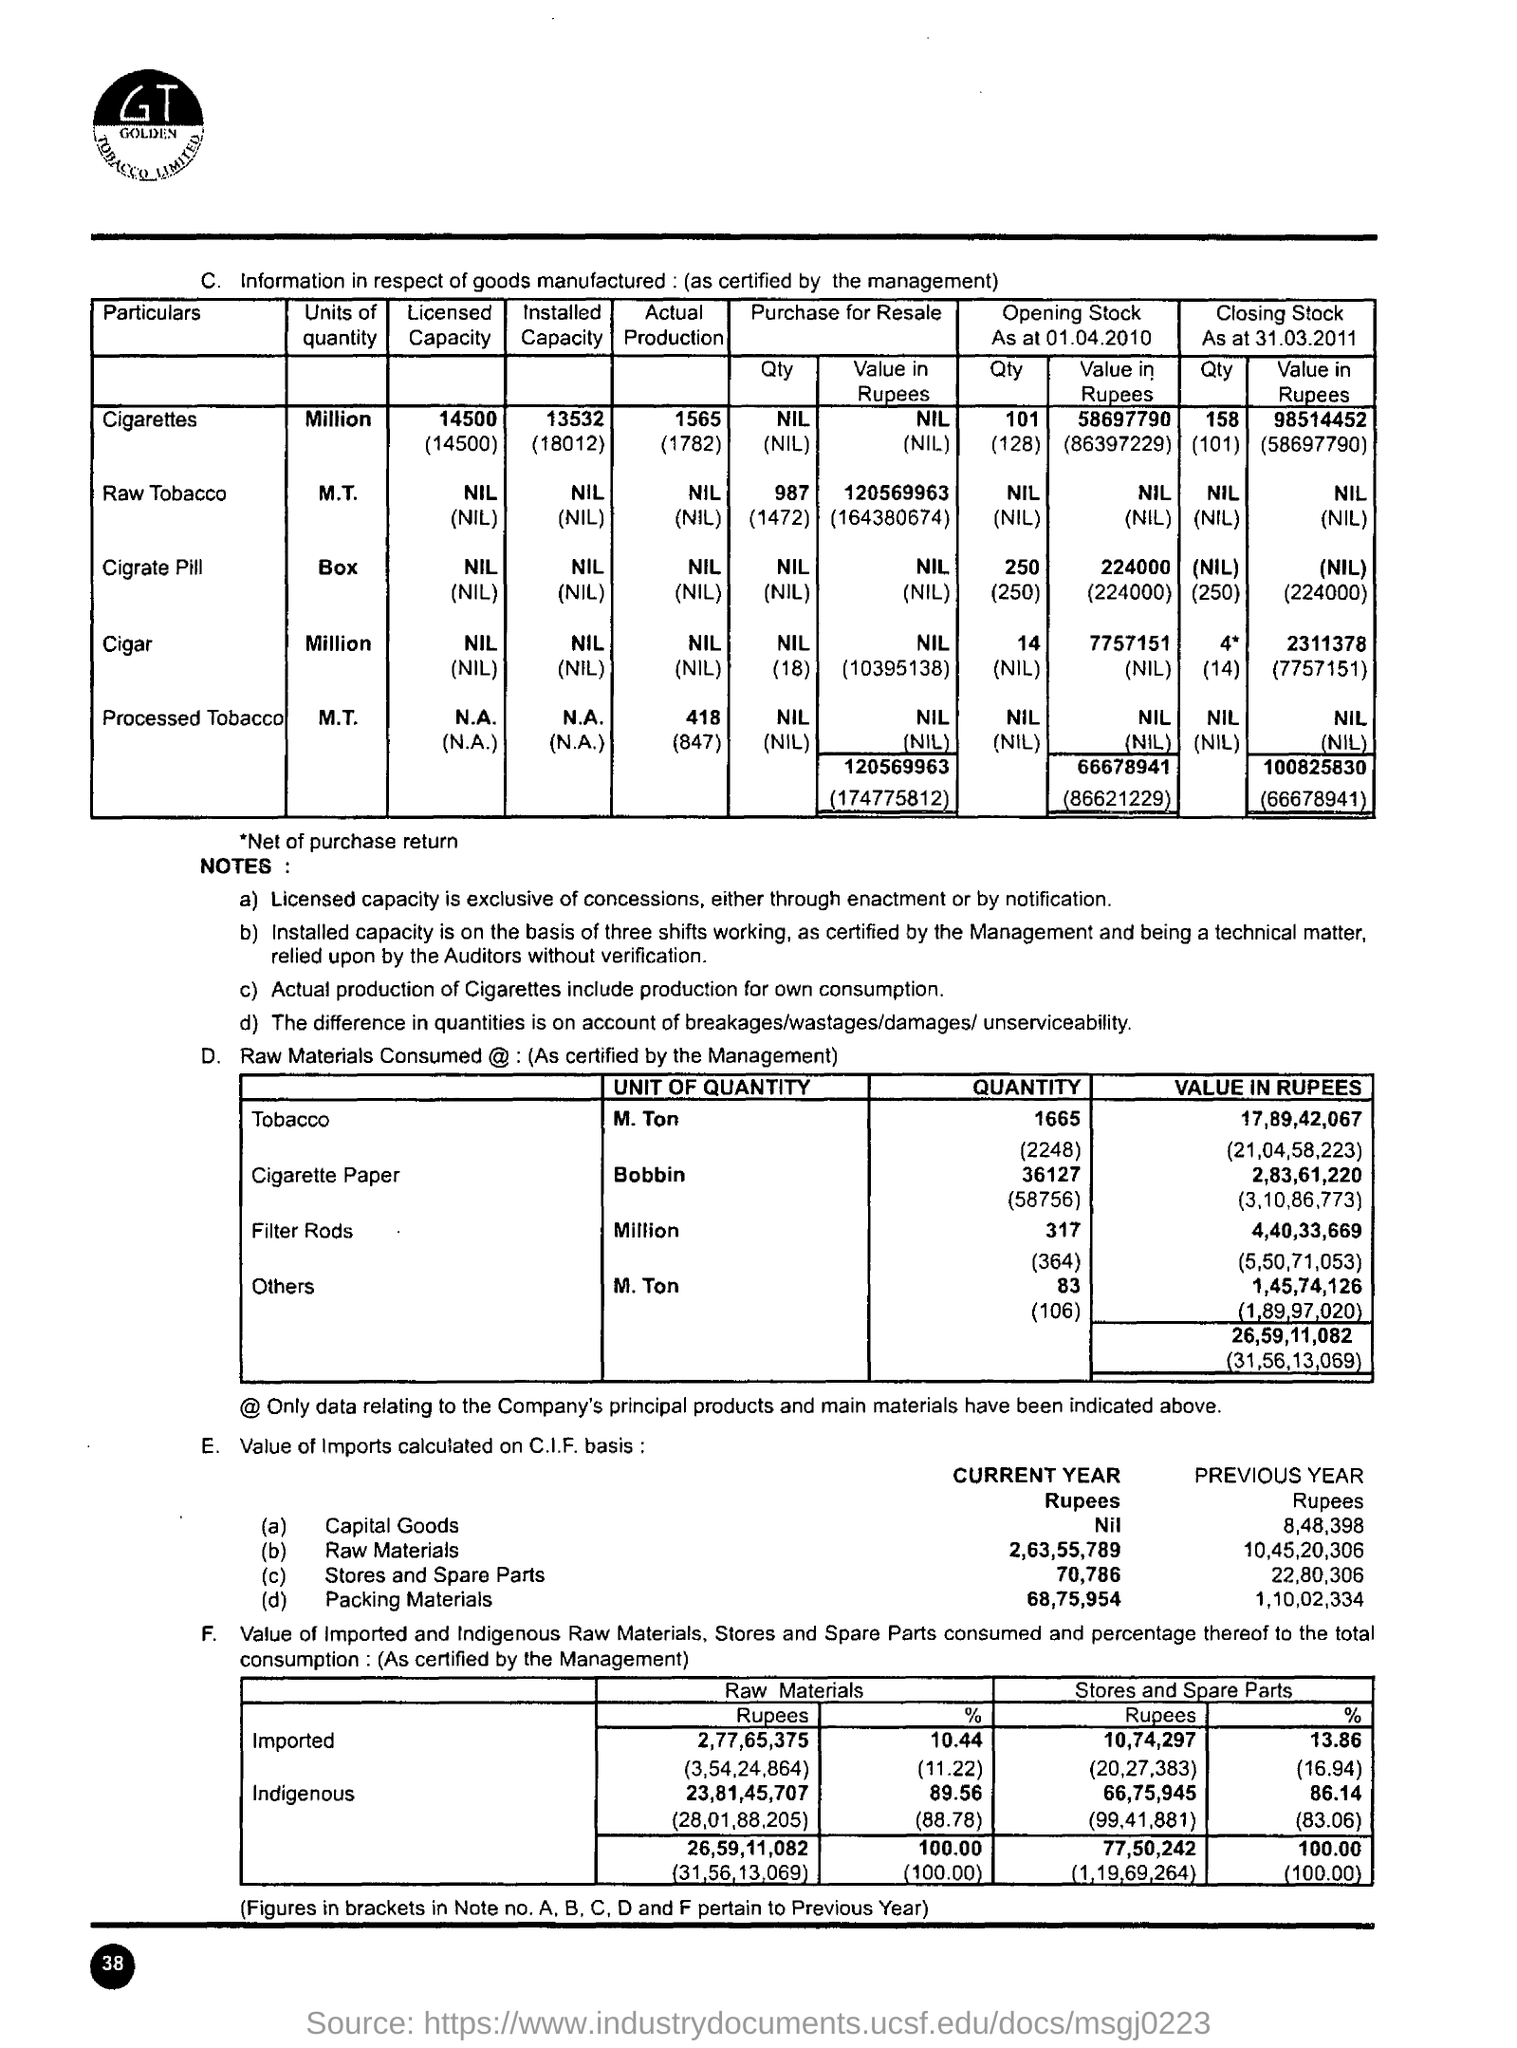Highlight a few significant elements in this photo. The value of tobacco in rupees is 17,89,42,067. Page 38 is the current page number. In the previous year, the value of imports of stores and spare parts calculated on the Cost, Insurance, and Freight (C.I.F) basis was 22,80,306. The value of imports of raw materials calculated on a Cost, Insurance, and Freight (C.I.F) basis in the current year is 2,63,55,789. The value of imports of packing materials calculated on a C.I.F basis in the current year is 68,75,954. 